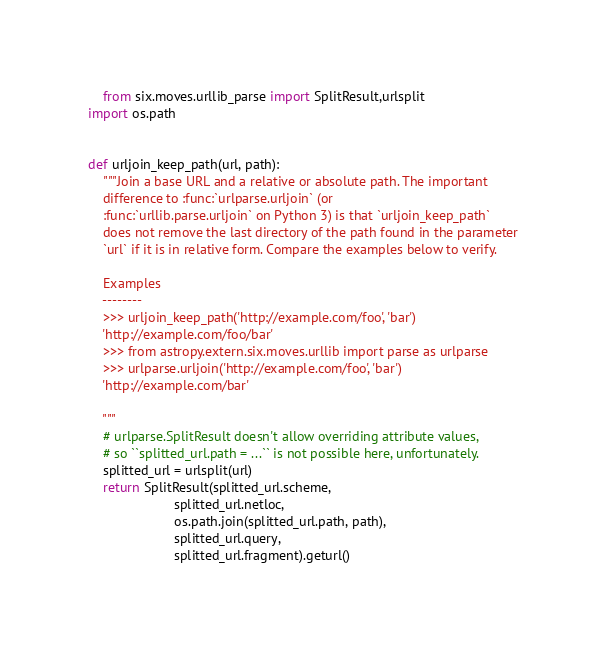Convert code to text. <code><loc_0><loc_0><loc_500><loc_500><_Python_>    from six.moves.urllib_parse import SplitResult,urlsplit
import os.path


def urljoin_keep_path(url, path):
    """Join a base URL and a relative or absolute path. The important
    difference to :func:`urlparse.urljoin` (or
    :func:`urllib.parse.urljoin` on Python 3) is that `urljoin_keep_path`
    does not remove the last directory of the path found in the parameter
    `url` if it is in relative form. Compare the examples below to verify.

    Examples
    --------
    >>> urljoin_keep_path('http://example.com/foo', 'bar')
    'http://example.com/foo/bar'
    >>> from astropy.extern.six.moves.urllib import parse as urlparse
    >>> urlparse.urljoin('http://example.com/foo', 'bar')
    'http://example.com/bar'

    """
    # urlparse.SplitResult doesn't allow overriding attribute values,
    # so ``splitted_url.path = ...`` is not possible here, unfortunately.
    splitted_url = urlsplit(url)
    return SplitResult(splitted_url.scheme,
                       splitted_url.netloc,
                       os.path.join(splitted_url.path, path),
                       splitted_url.query,
                       splitted_url.fragment).geturl()
</code> 